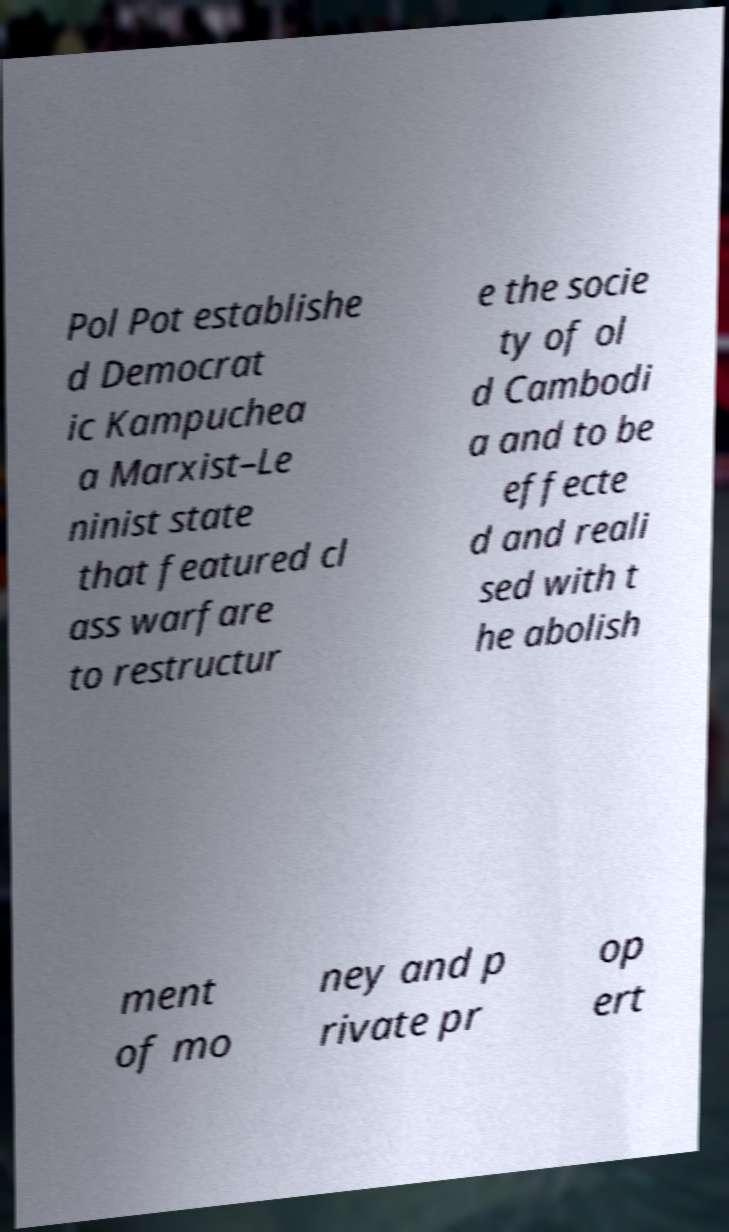For documentation purposes, I need the text within this image transcribed. Could you provide that? Pol Pot establishe d Democrat ic Kampuchea a Marxist–Le ninist state that featured cl ass warfare to restructur e the socie ty of ol d Cambodi a and to be effecte d and reali sed with t he abolish ment of mo ney and p rivate pr op ert 